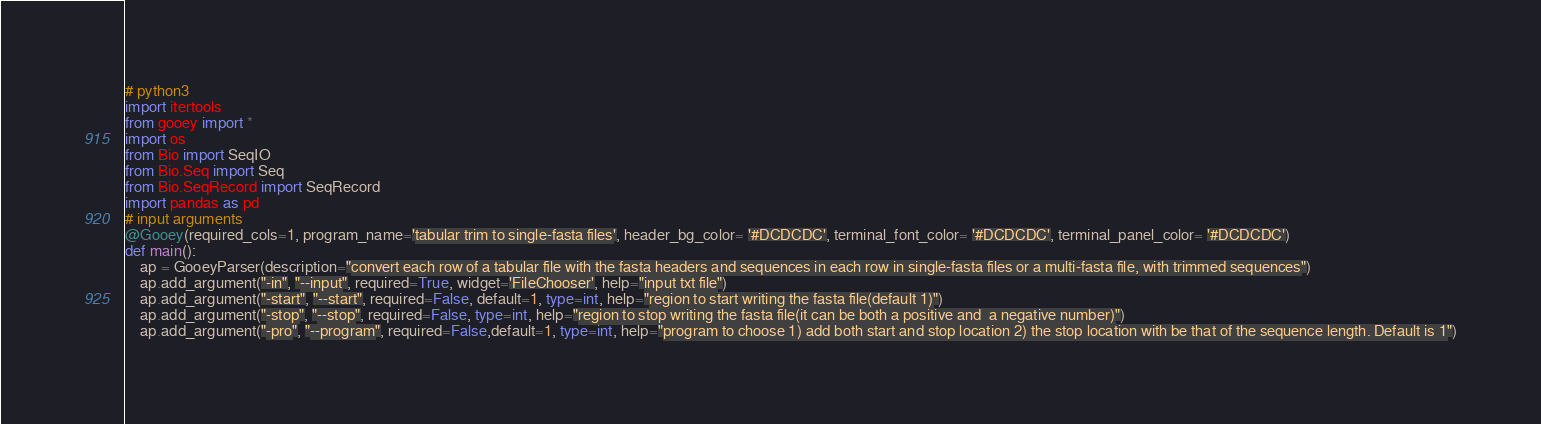<code> <loc_0><loc_0><loc_500><loc_500><_Python_># python3
import itertools
from gooey import *
import os
from Bio import SeqIO
from Bio.Seq import Seq
from Bio.SeqRecord import SeqRecord
import pandas as pd
# input arguments
@Gooey(required_cols=1, program_name='tabular trim to single-fasta files', header_bg_color= '#DCDCDC', terminal_font_color= '#DCDCDC', terminal_panel_color= '#DCDCDC')
def main():
    ap = GooeyParser(description="convert each row of a tabular file with the fasta headers and sequences in each row in single-fasta files or a multi-fasta file, with trimmed sequences") 
    ap.add_argument("-in", "--input", required=True, widget='FileChooser', help="input txt file")
    ap.add_argument("-start", "--start", required=False, default=1, type=int, help="region to start writing the fasta file(default 1)")
    ap.add_argument("-stop", "--stop", required=False, type=int, help="region to stop writing the fasta file(it can be both a positive and  a negative number)")
    ap.add_argument("-pro", "--program", required=False,default=1, type=int, help="program to choose 1) add both start and stop location 2) the stop location with be that of the sequence length. Default is 1")</code> 